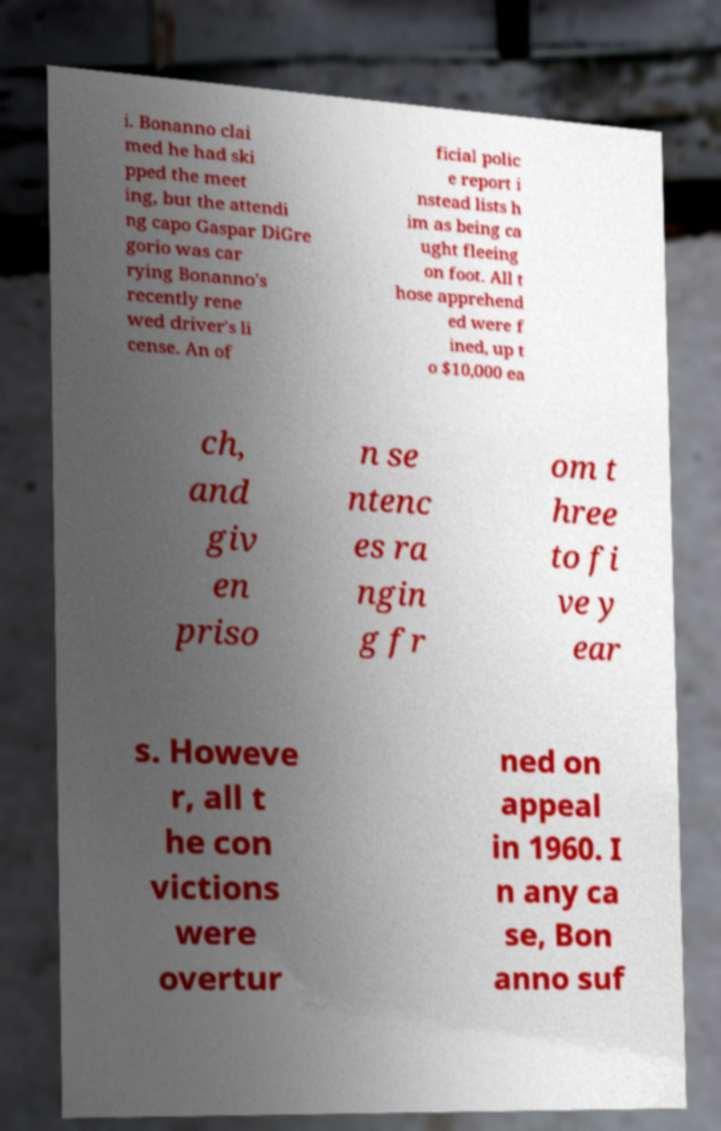Could you assist in decoding the text presented in this image and type it out clearly? i. Bonanno clai med he had ski pped the meet ing, but the attendi ng capo Gaspar DiGre gorio was car rying Bonanno's recently rene wed driver's li cense. An of ficial polic e report i nstead lists h im as being ca ught fleeing on foot. All t hose apprehend ed were f ined, up t o $10,000 ea ch, and giv en priso n se ntenc es ra ngin g fr om t hree to fi ve y ear s. Howeve r, all t he con victions were overtur ned on appeal in 1960. I n any ca se, Bon anno suf 